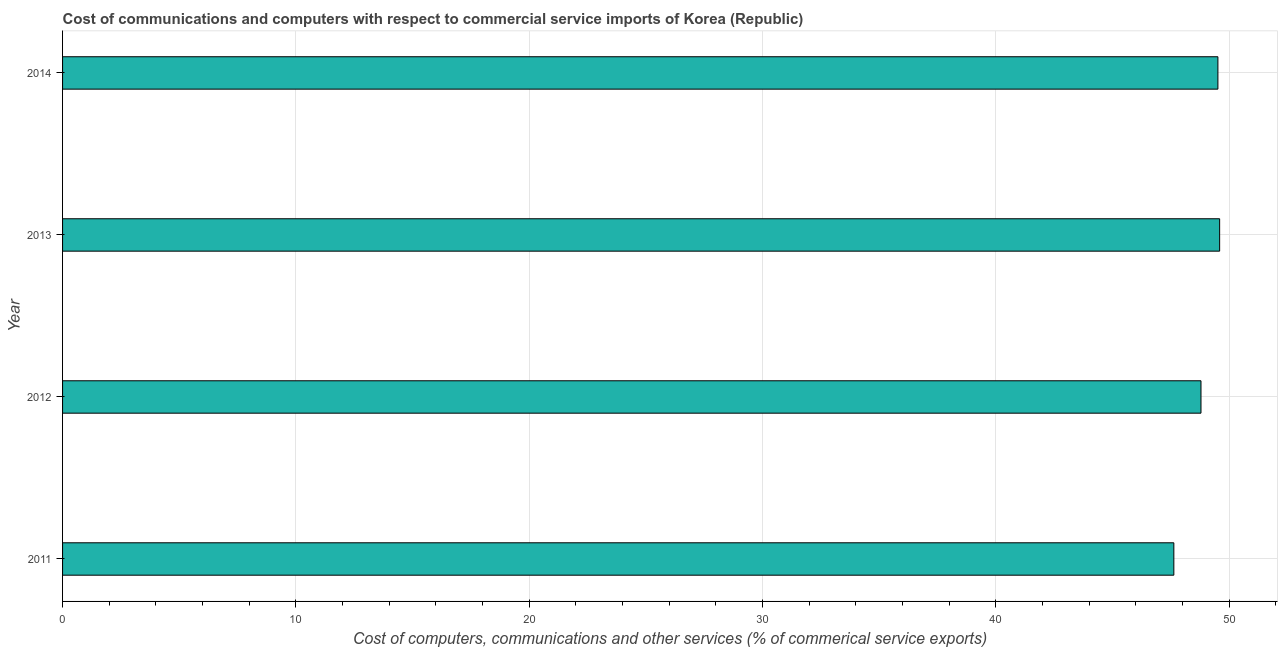Does the graph contain any zero values?
Your answer should be compact. No. What is the title of the graph?
Provide a short and direct response. Cost of communications and computers with respect to commercial service imports of Korea (Republic). What is the label or title of the X-axis?
Make the answer very short. Cost of computers, communications and other services (% of commerical service exports). What is the  computer and other services in 2012?
Offer a terse response. 48.79. Across all years, what is the maximum cost of communications?
Your answer should be very brief. 49.59. Across all years, what is the minimum  computer and other services?
Offer a very short reply. 47.62. In which year was the  computer and other services minimum?
Your answer should be compact. 2011. What is the sum of the cost of communications?
Your response must be concise. 195.51. What is the difference between the  computer and other services in 2012 and 2014?
Offer a terse response. -0.72. What is the average  computer and other services per year?
Provide a succinct answer. 48.88. What is the median  computer and other services?
Your answer should be compact. 49.15. In how many years, is the  computer and other services greater than 8 %?
Your response must be concise. 4. Is the difference between the cost of communications in 2011 and 2013 greater than the difference between any two years?
Your answer should be very brief. Yes. What is the difference between the highest and the second highest cost of communications?
Offer a very short reply. 0.07. What is the difference between the highest and the lowest  computer and other services?
Ensure brevity in your answer.  1.96. In how many years, is the cost of communications greater than the average cost of communications taken over all years?
Your response must be concise. 2. Are all the bars in the graph horizontal?
Provide a succinct answer. Yes. How many years are there in the graph?
Your answer should be very brief. 4. What is the difference between two consecutive major ticks on the X-axis?
Provide a short and direct response. 10. Are the values on the major ticks of X-axis written in scientific E-notation?
Offer a very short reply. No. What is the Cost of computers, communications and other services (% of commerical service exports) in 2011?
Keep it short and to the point. 47.62. What is the Cost of computers, communications and other services (% of commerical service exports) in 2012?
Ensure brevity in your answer.  48.79. What is the Cost of computers, communications and other services (% of commerical service exports) of 2013?
Your response must be concise. 49.59. What is the Cost of computers, communications and other services (% of commerical service exports) in 2014?
Make the answer very short. 49.51. What is the difference between the Cost of computers, communications and other services (% of commerical service exports) in 2011 and 2012?
Provide a short and direct response. -1.16. What is the difference between the Cost of computers, communications and other services (% of commerical service exports) in 2011 and 2013?
Your answer should be very brief. -1.96. What is the difference between the Cost of computers, communications and other services (% of commerical service exports) in 2011 and 2014?
Offer a terse response. -1.89. What is the difference between the Cost of computers, communications and other services (% of commerical service exports) in 2012 and 2013?
Keep it short and to the point. -0.8. What is the difference between the Cost of computers, communications and other services (% of commerical service exports) in 2012 and 2014?
Your response must be concise. -0.73. What is the difference between the Cost of computers, communications and other services (% of commerical service exports) in 2013 and 2014?
Keep it short and to the point. 0.07. What is the ratio of the Cost of computers, communications and other services (% of commerical service exports) in 2011 to that in 2013?
Make the answer very short. 0.96. 